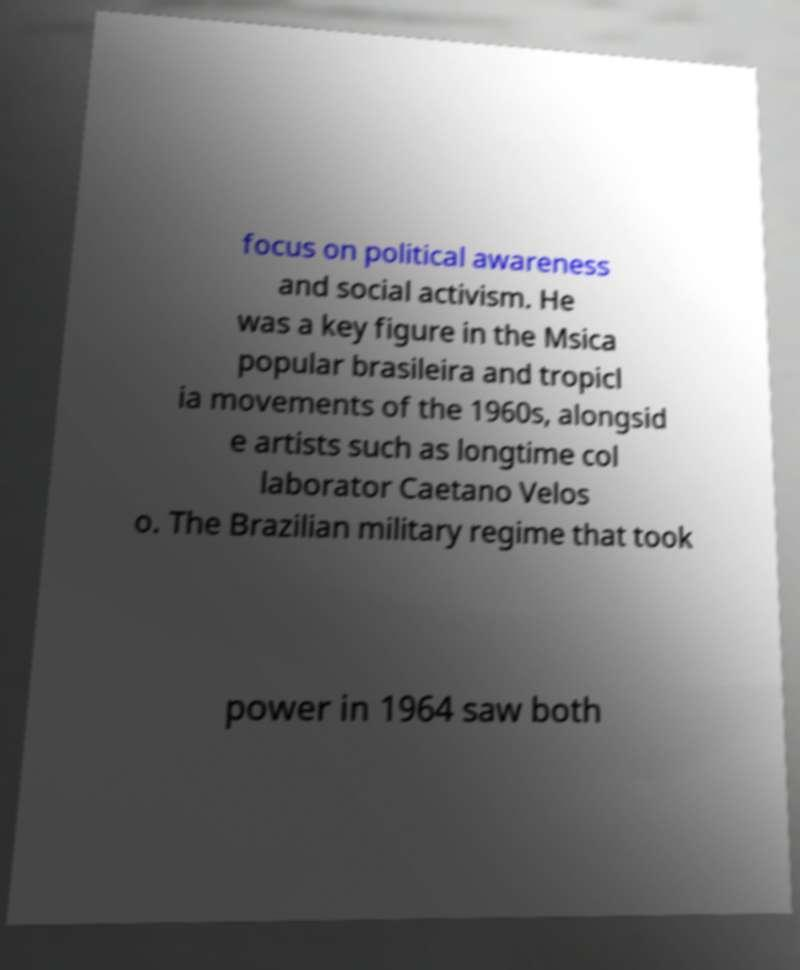There's text embedded in this image that I need extracted. Can you transcribe it verbatim? focus on political awareness and social activism. He was a key figure in the Msica popular brasileira and tropicl ia movements of the 1960s, alongsid e artists such as longtime col laborator Caetano Velos o. The Brazilian military regime that took power in 1964 saw both 